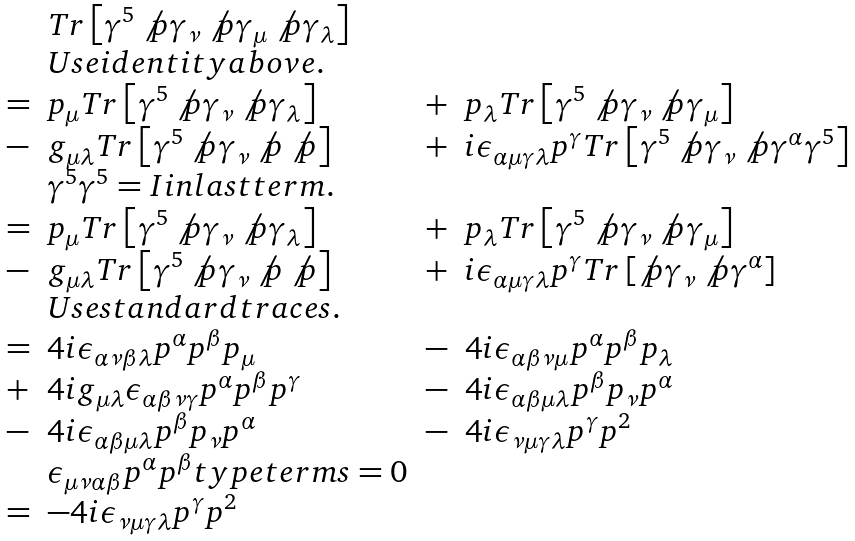<formula> <loc_0><loc_0><loc_500><loc_500>\begin{array} { l l l l } & T r \left [ \gamma ^ { 5 } \not p \gamma _ { \nu } \not p \gamma _ { \mu } \not p \gamma _ { \lambda } \right ] \\ & U s e i d e n t i t y a b o v e . \\ = & p _ { \mu } T r \left [ \gamma ^ { 5 } \not p \gamma _ { \nu } \not p \gamma _ { \lambda } \right ] & + & p _ { \lambda } T r \left [ \gamma ^ { 5 } \not p \gamma _ { \nu } \not p \gamma _ { \mu } \right ] \\ - & g _ { \mu \lambda } T r \left [ \gamma ^ { 5 } \not p \gamma _ { \nu } \not p \not p \right ] & + & i \epsilon _ { \alpha \mu \gamma \lambda } p ^ { \gamma } T r \left [ \gamma ^ { 5 } \not p \gamma _ { \nu } \not p \gamma ^ { \alpha } \gamma ^ { 5 } \right ] \\ & \gamma ^ { 5 } \gamma ^ { 5 } = I i n l a s t t e r m . \\ = & p _ { \mu } T r \left [ \gamma ^ { 5 } \not p \gamma _ { \nu } \not p \gamma _ { \lambda } \right ] & + & p _ { \lambda } T r \left [ \gamma ^ { 5 } \not p \gamma _ { \nu } \not p \gamma _ { \mu } \right ] \\ - & g _ { \mu \lambda } T r \left [ \gamma ^ { 5 } \not p \gamma _ { \nu } \not p \not p \right ] & + & i \epsilon _ { \alpha \mu \gamma \lambda } p ^ { \gamma } T r \left [ \not p \gamma _ { \nu } \not p \gamma ^ { \alpha } \right ] \\ & U s e s t a n d a r d t r a c e s . \\ = & 4 i \epsilon _ { \alpha \nu \beta \lambda } p ^ { \alpha } p ^ { \beta } p _ { \mu } & - & 4 i \epsilon _ { \alpha \beta \nu \mu } p ^ { \alpha } p ^ { \beta } p _ { \lambda } \\ + & 4 i g _ { \mu \lambda } \epsilon _ { \alpha \beta \nu \gamma } p ^ { \alpha } p ^ { \beta } p ^ { \gamma } & - & 4 i \epsilon _ { \alpha \beta \mu \lambda } p ^ { \beta } p _ { \nu } p ^ { \alpha } \\ - & 4 i \epsilon _ { \alpha \beta \mu \lambda } p ^ { \beta } p _ { \nu } p ^ { \alpha } & - & 4 i \epsilon _ { \nu \mu \gamma \lambda } p ^ { \gamma } p ^ { 2 } \\ & \epsilon _ { \mu \nu \alpha \beta } p ^ { \alpha } p ^ { \beta } t y p e t e r m s = 0 \\ = & - 4 i \epsilon _ { \nu \mu \gamma \lambda } p ^ { \gamma } p ^ { 2 } \end{array}</formula> 